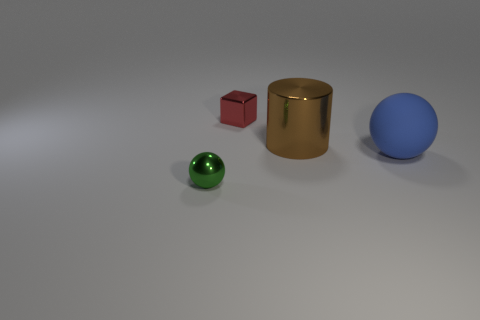There is a metal object in front of the shiny cylinder; is its size the same as the red shiny object?
Your answer should be compact. Yes. Do the large matte object and the metallic block have the same color?
Your answer should be very brief. No. How many small red objects are there?
Your response must be concise. 1. How many cylinders are big brown objects or small green things?
Your response must be concise. 1. What number of tiny metal cubes are in front of the small metallic object that is to the left of the red thing?
Keep it short and to the point. 0. Do the small red cube and the small green object have the same material?
Offer a terse response. Yes. Is there a small gray cube that has the same material as the cylinder?
Offer a very short reply. No. What color is the thing on the left side of the small metal object behind the small object that is in front of the large cylinder?
Your response must be concise. Green. How many blue things are large objects or big spheres?
Your response must be concise. 1. What number of metal objects are the same shape as the blue matte thing?
Offer a very short reply. 1. 